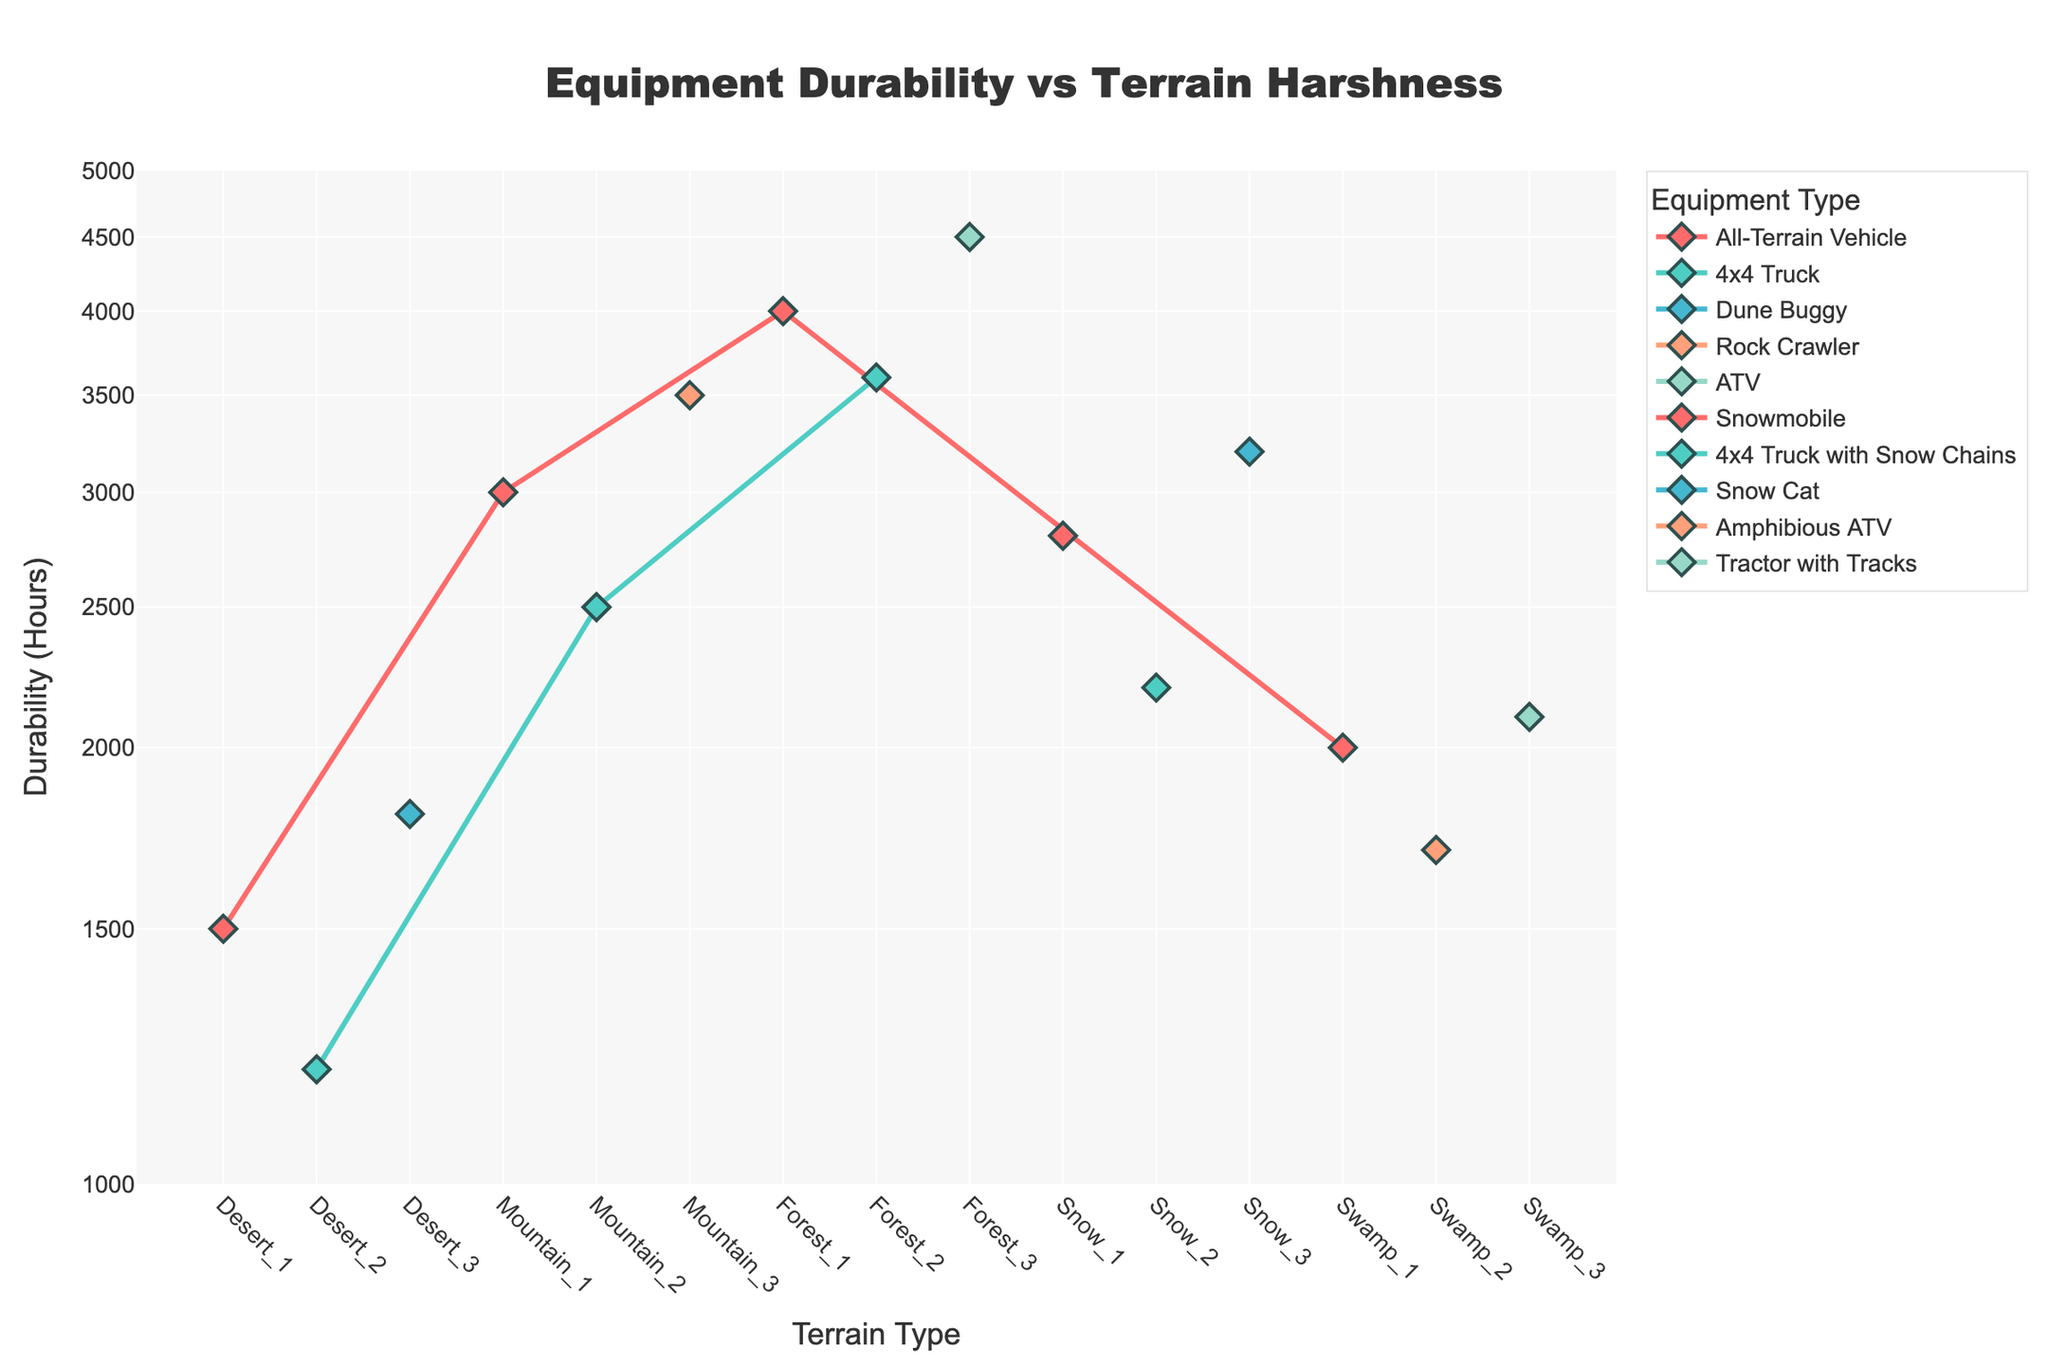Which equipment type has the highest durability in the forest terrain? By examining the plot, the highest point in the forest terrain is around 4500 durability hours. The equipment type corresponding to this is the ATV.
Answer: ATV What is the durability range for the 4x4 Truck across all terrains? Checking the plot, the 4x4 Truck has durability points at 1200, 2500, 3600, and 2200 hours. The lowest is 1200, and the highest is 3600, so the range is 3600 - 1200 = 2400 hours.
Answer: 2400 hours How does the durability of the All-Terrain Vehicle compare between desert and swamp terrains? For the desert, the All-Terrain Vehicle's durability is 1500 hours. In the swamp, it is 2000 hours. Hence, it lasts 500 hours longer in the swamp.
Answer: 500 hours longer in the swamp Which terrain type sees the most considerable durability variation for a single equipment type? By comparing the vertical spread of points for each equipment type in various terrains, the 4x4 Truck shows high variations from 1200 in desert to 3600 in forest, indicating a variation of 2400 hours.
Answer: Forest terrain What is the average durability of all equipment types in the snow terrain? Durability hours in snow for all equipment types are 2800, 2200, and 3200. Summing them is 2800 + 2200 + 3200 = 8200, and the average is 8200/3 ≈ 2733 hours.
Answer: ~2733 hours Between the Rock Crawler in the mountains and the Snow Cat in the snow, which one has higher durability? The Rock Crawler in mountains has 3500 hours of durability, whereas the Snow Cat in snow has 3200. Comparing these values, the Rock Crawler has a higher durability.
Answer: Rock Crawler Does any equipment type have consistently high durability across multiple terrain types? Observing the plot, the All-Terrain Vehicle shows high durability across forest (4000), mountain (3000), and swamp (2000) terrains though it is not consistently the highest overall. It's high but not the highest.
Answer: No Which terrain contains the equipment with the lowest durability, and what is it? Looking at the lowest point on the plot overall, in the desert terrain, the 4x4 Truck has the lowest durability at 1200 hours.
Answer: Desert, 4x4 Truck, 1200 hours What’s the difference in durability between the Amphibious ATV in the swamp and the Snowmobile in the snow? The Amphibious ATV in swamp has 1700 hours of durability, while the Snowmobile in snow has 2800 hours. The difference is 2800 - 1700 = 1100 hours.
Answer: 1100 hours During which terrain does the average equipment type durability exceed 3000 hours? Calculate averages for terrains: 
Desert = (1500+1200+1800)/3 = 1500 hours
Mountain = (3000+2500+3500)/3 ≈ 3000 hours
Forest = (4000+3600+4500)/3 ≈ 4033 hours
Snow = (2800+2200+3200)/3 ≈ 2733 hours
Swamp = (2000+1700+2100)/3 ≈ 1933 hours
The forest terrain average exceeds 3000 hours.
Answer: Forest 